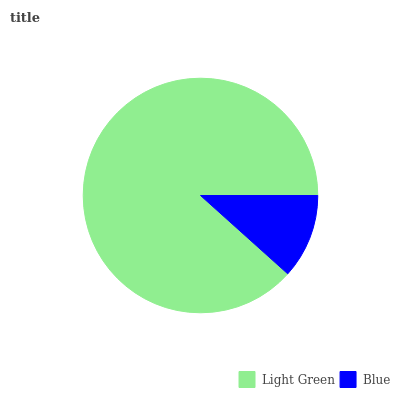Is Blue the minimum?
Answer yes or no. Yes. Is Light Green the maximum?
Answer yes or no. Yes. Is Blue the maximum?
Answer yes or no. No. Is Light Green greater than Blue?
Answer yes or no. Yes. Is Blue less than Light Green?
Answer yes or no. Yes. Is Blue greater than Light Green?
Answer yes or no. No. Is Light Green less than Blue?
Answer yes or no. No. Is Light Green the high median?
Answer yes or no. Yes. Is Blue the low median?
Answer yes or no. Yes. Is Blue the high median?
Answer yes or no. No. Is Light Green the low median?
Answer yes or no. No. 